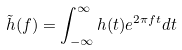<formula> <loc_0><loc_0><loc_500><loc_500>\tilde { h } ( f ) = \int _ { - \infty } ^ { \infty } h ( t ) e ^ { 2 \pi f t } d t</formula> 